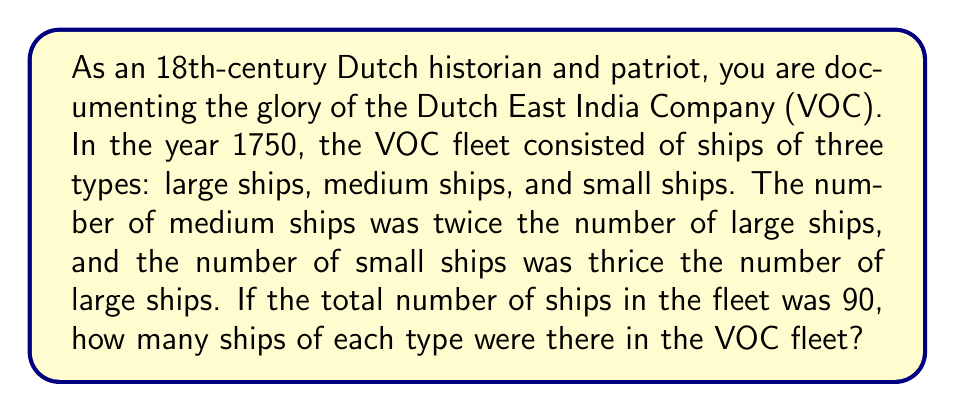Show me your answer to this math problem. Let's approach this problem step by step:

1. Let $x$ represent the number of large ships.

2. Given the information in the question:
   - Number of medium ships $= 2x$
   - Number of small ships $= 3x$

3. The total number of ships is 90, so we can set up the equation:
   $$x + 2x + 3x = 90$$

4. Simplify the left side of the equation:
   $$6x = 90$$

5. Solve for $x$:
   $$x = 90 \div 6 = 15$$

6. Now that we know the number of large ships, we can calculate the others:
   - Number of large ships $= x = 15$
   - Number of medium ships $= 2x = 2(15) = 30$
   - Number of small ships $= 3x = 3(15) = 45$

7. Verify the solution:
   $$15 + 30 + 45 = 90$$

This confirms that our calculation is correct and matches the total fleet size given in the problem.
Answer: The Dutch East India Company fleet in 1750 consisted of:
- 15 large ships
- 30 medium ships
- 45 small ships 